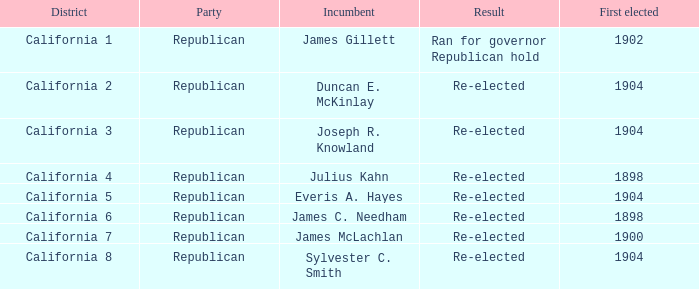Which Incumbent has a District of California 5? Everis A. Hayes. 